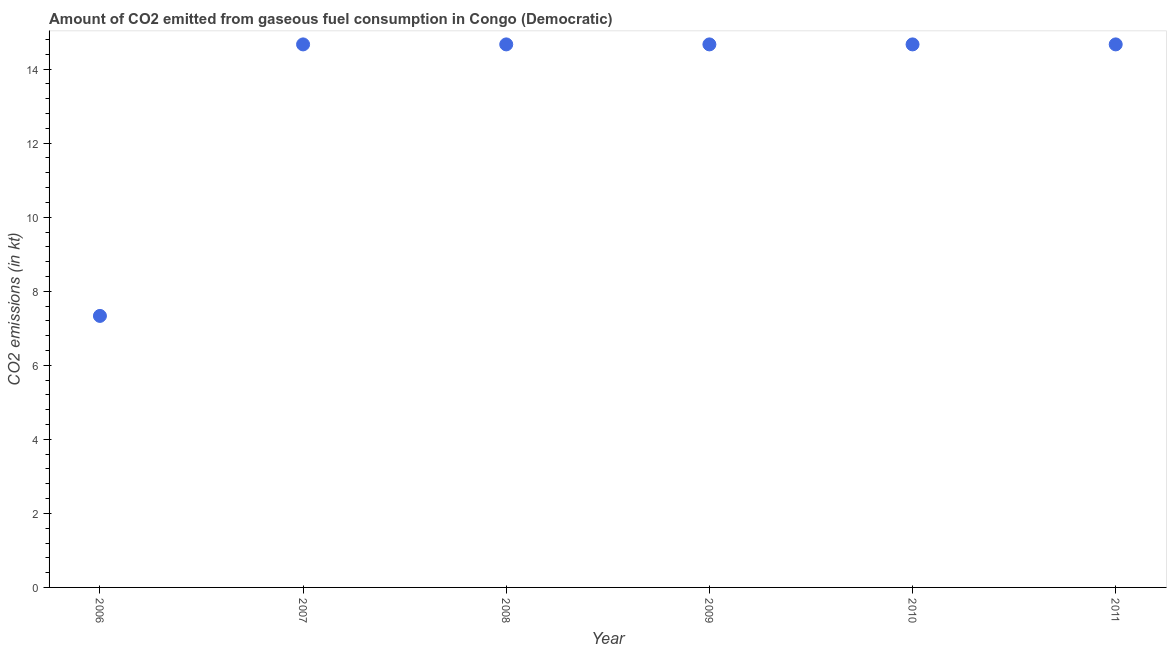What is the co2 emissions from gaseous fuel consumption in 2006?
Give a very brief answer. 7.33. Across all years, what is the maximum co2 emissions from gaseous fuel consumption?
Your response must be concise. 14.67. Across all years, what is the minimum co2 emissions from gaseous fuel consumption?
Your answer should be compact. 7.33. What is the sum of the co2 emissions from gaseous fuel consumption?
Your response must be concise. 80.67. What is the difference between the co2 emissions from gaseous fuel consumption in 2007 and 2011?
Offer a very short reply. 0. What is the average co2 emissions from gaseous fuel consumption per year?
Keep it short and to the point. 13.45. What is the median co2 emissions from gaseous fuel consumption?
Make the answer very short. 14.67. In how many years, is the co2 emissions from gaseous fuel consumption greater than 13.2 kt?
Your answer should be very brief. 5. What is the ratio of the co2 emissions from gaseous fuel consumption in 2009 to that in 2011?
Your answer should be compact. 1. Is the sum of the co2 emissions from gaseous fuel consumption in 2008 and 2010 greater than the maximum co2 emissions from gaseous fuel consumption across all years?
Give a very brief answer. Yes. What is the difference between the highest and the lowest co2 emissions from gaseous fuel consumption?
Ensure brevity in your answer.  7.33. In how many years, is the co2 emissions from gaseous fuel consumption greater than the average co2 emissions from gaseous fuel consumption taken over all years?
Offer a very short reply. 5. How many dotlines are there?
Offer a terse response. 1. Are the values on the major ticks of Y-axis written in scientific E-notation?
Provide a short and direct response. No. What is the title of the graph?
Your answer should be compact. Amount of CO2 emitted from gaseous fuel consumption in Congo (Democratic). What is the label or title of the X-axis?
Your response must be concise. Year. What is the label or title of the Y-axis?
Provide a short and direct response. CO2 emissions (in kt). What is the CO2 emissions (in kt) in 2006?
Provide a succinct answer. 7.33. What is the CO2 emissions (in kt) in 2007?
Make the answer very short. 14.67. What is the CO2 emissions (in kt) in 2008?
Keep it short and to the point. 14.67. What is the CO2 emissions (in kt) in 2009?
Make the answer very short. 14.67. What is the CO2 emissions (in kt) in 2010?
Your response must be concise. 14.67. What is the CO2 emissions (in kt) in 2011?
Make the answer very short. 14.67. What is the difference between the CO2 emissions (in kt) in 2006 and 2007?
Your answer should be very brief. -7.33. What is the difference between the CO2 emissions (in kt) in 2006 and 2008?
Provide a succinct answer. -7.33. What is the difference between the CO2 emissions (in kt) in 2006 and 2009?
Your answer should be very brief. -7.33. What is the difference between the CO2 emissions (in kt) in 2006 and 2010?
Make the answer very short. -7.33. What is the difference between the CO2 emissions (in kt) in 2006 and 2011?
Provide a succinct answer. -7.33. What is the difference between the CO2 emissions (in kt) in 2007 and 2009?
Ensure brevity in your answer.  0. What is the difference between the CO2 emissions (in kt) in 2007 and 2010?
Provide a succinct answer. 0. What is the difference between the CO2 emissions (in kt) in 2008 and 2009?
Give a very brief answer. 0. What is the difference between the CO2 emissions (in kt) in 2008 and 2010?
Your answer should be very brief. 0. What is the difference between the CO2 emissions (in kt) in 2008 and 2011?
Provide a succinct answer. 0. What is the difference between the CO2 emissions (in kt) in 2009 and 2011?
Offer a very short reply. 0. What is the ratio of the CO2 emissions (in kt) in 2006 to that in 2008?
Your answer should be very brief. 0.5. What is the ratio of the CO2 emissions (in kt) in 2006 to that in 2009?
Give a very brief answer. 0.5. What is the ratio of the CO2 emissions (in kt) in 2007 to that in 2008?
Ensure brevity in your answer.  1. What is the ratio of the CO2 emissions (in kt) in 2007 to that in 2011?
Give a very brief answer. 1. What is the ratio of the CO2 emissions (in kt) in 2008 to that in 2009?
Ensure brevity in your answer.  1. What is the ratio of the CO2 emissions (in kt) in 2008 to that in 2010?
Give a very brief answer. 1. What is the ratio of the CO2 emissions (in kt) in 2009 to that in 2010?
Offer a terse response. 1. What is the ratio of the CO2 emissions (in kt) in 2009 to that in 2011?
Offer a very short reply. 1. 